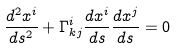<formula> <loc_0><loc_0><loc_500><loc_500>\frac { d ^ { 2 } x ^ { i } } { d s ^ { 2 } } + \Gamma ^ { i } _ { k j } \frac { d x ^ { i } } { d s } \frac { d x ^ { j } } { d s } = 0</formula> 